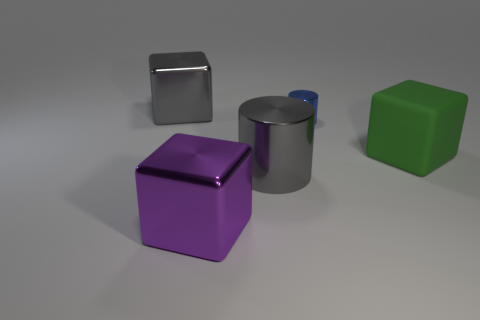Subtract all metal blocks. How many blocks are left? 1 Add 3 purple blocks. How many objects exist? 8 Subtract all green blocks. How many blocks are left? 2 Subtract 3 cubes. How many cubes are left? 0 Subtract 0 yellow cylinders. How many objects are left? 5 Subtract all cubes. How many objects are left? 2 Subtract all gray cylinders. Subtract all purple spheres. How many cylinders are left? 1 Subtract all blue spheres. How many blue cylinders are left? 1 Subtract all red metal cylinders. Subtract all large objects. How many objects are left? 1 Add 3 gray objects. How many gray objects are left? 5 